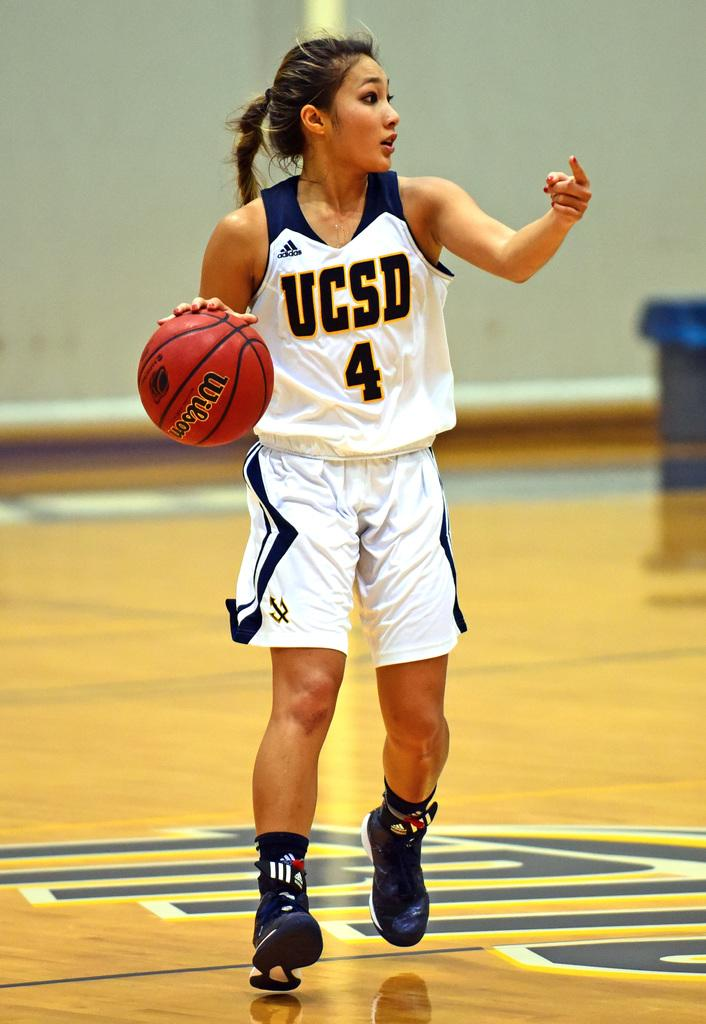Provide a one-sentence caption for the provided image. Female basketball player dribbling a basketball while wearing a "UCSD" jersey. 